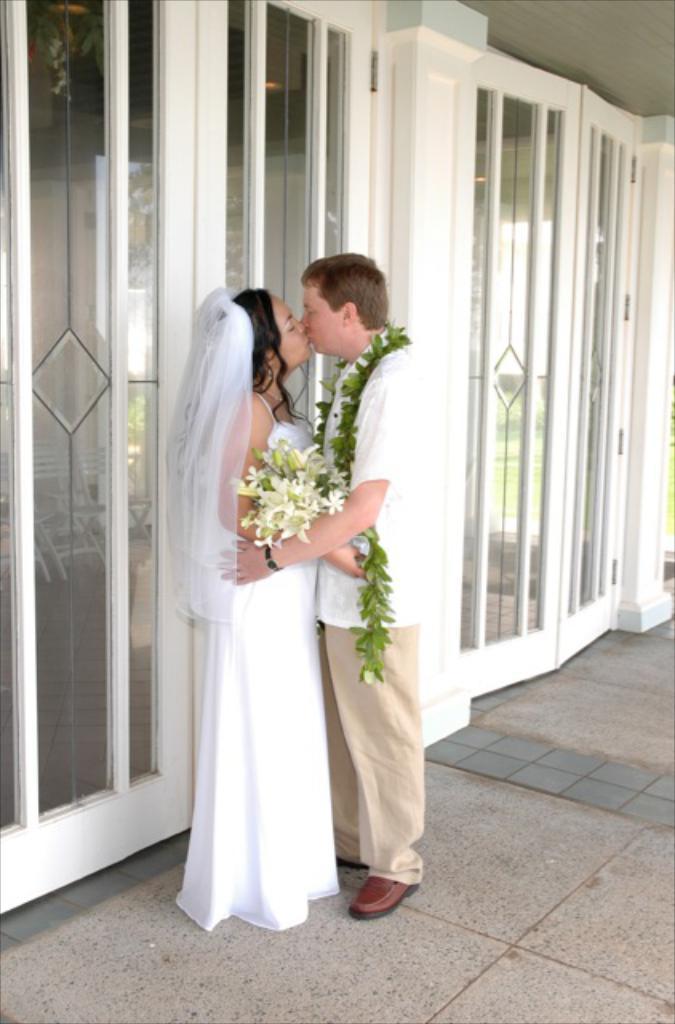How would you summarize this image in a sentence or two? In the middle a man is standing and kissing this girl, he wore white color shirt, this girl wore white color dress, these are the glass windows and doors. 